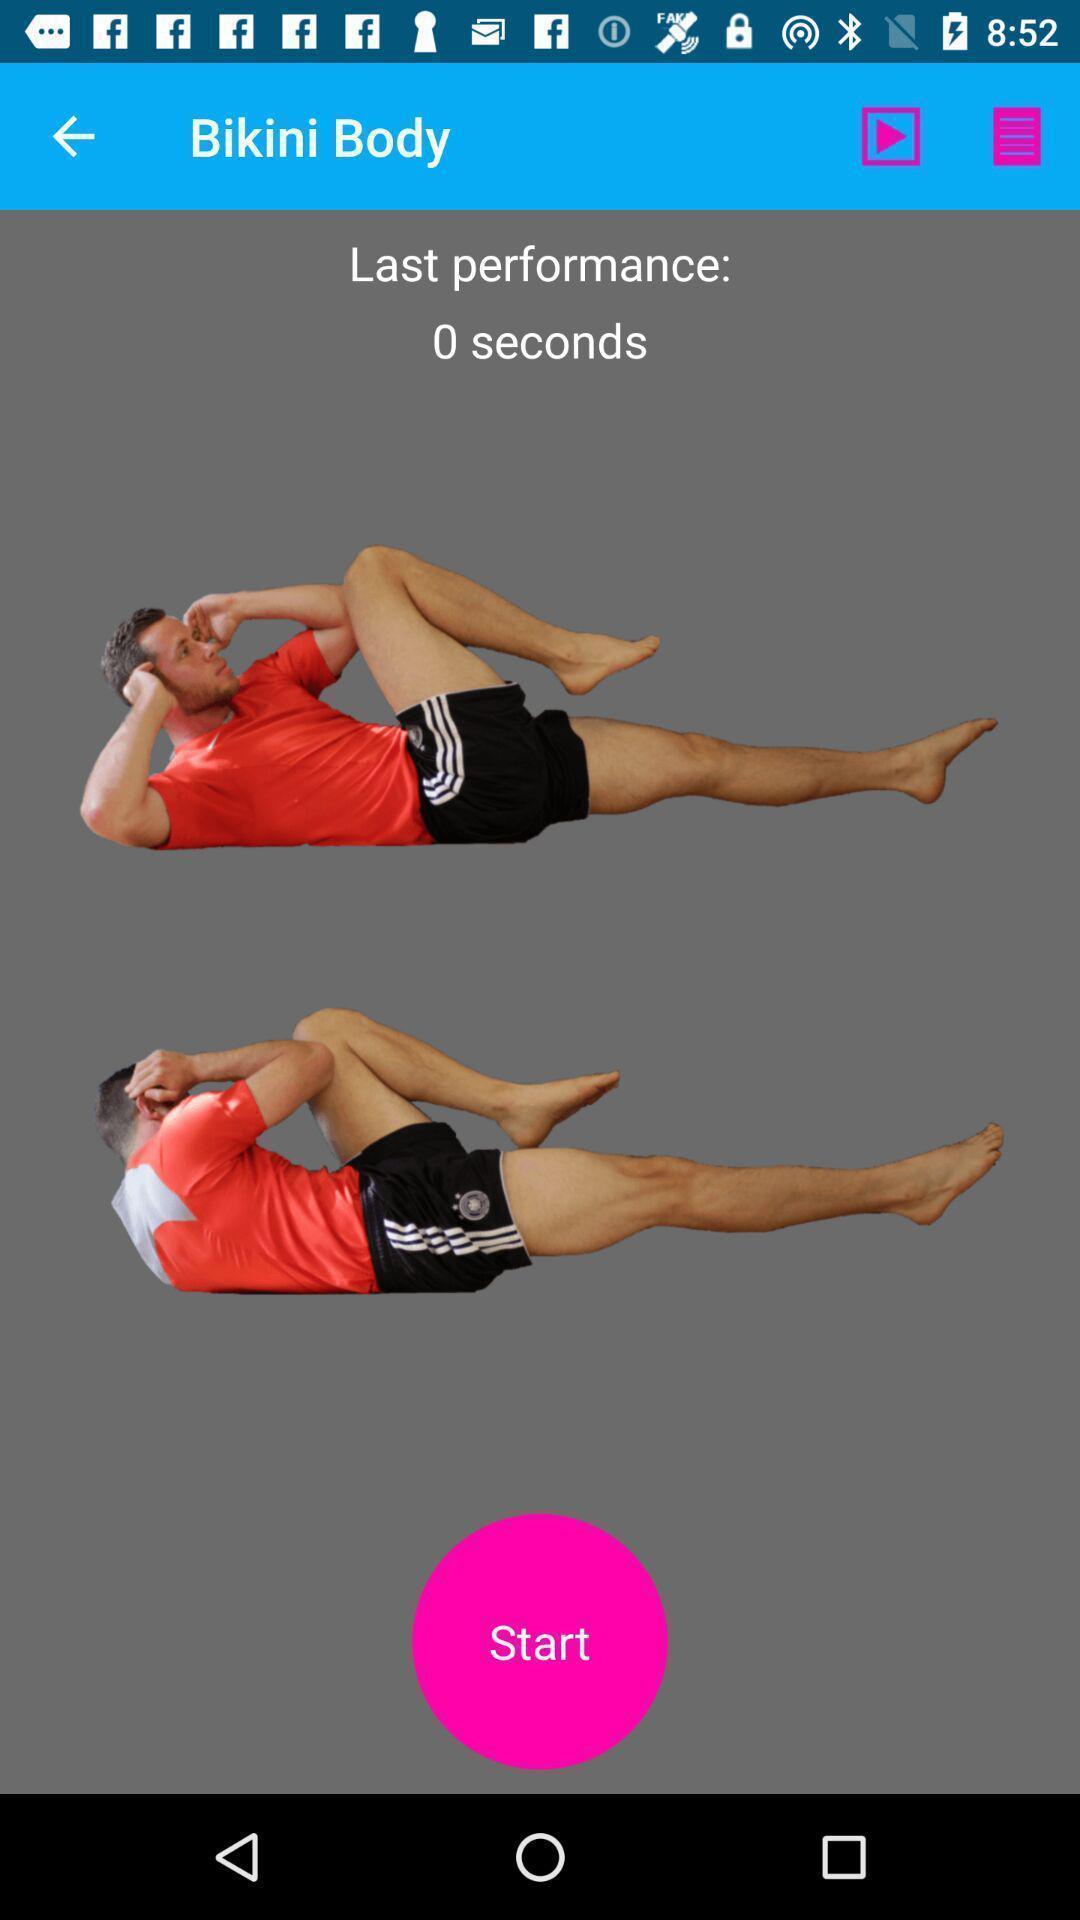What details can you identify in this image? Screen showing exercise poses in fitness app. 